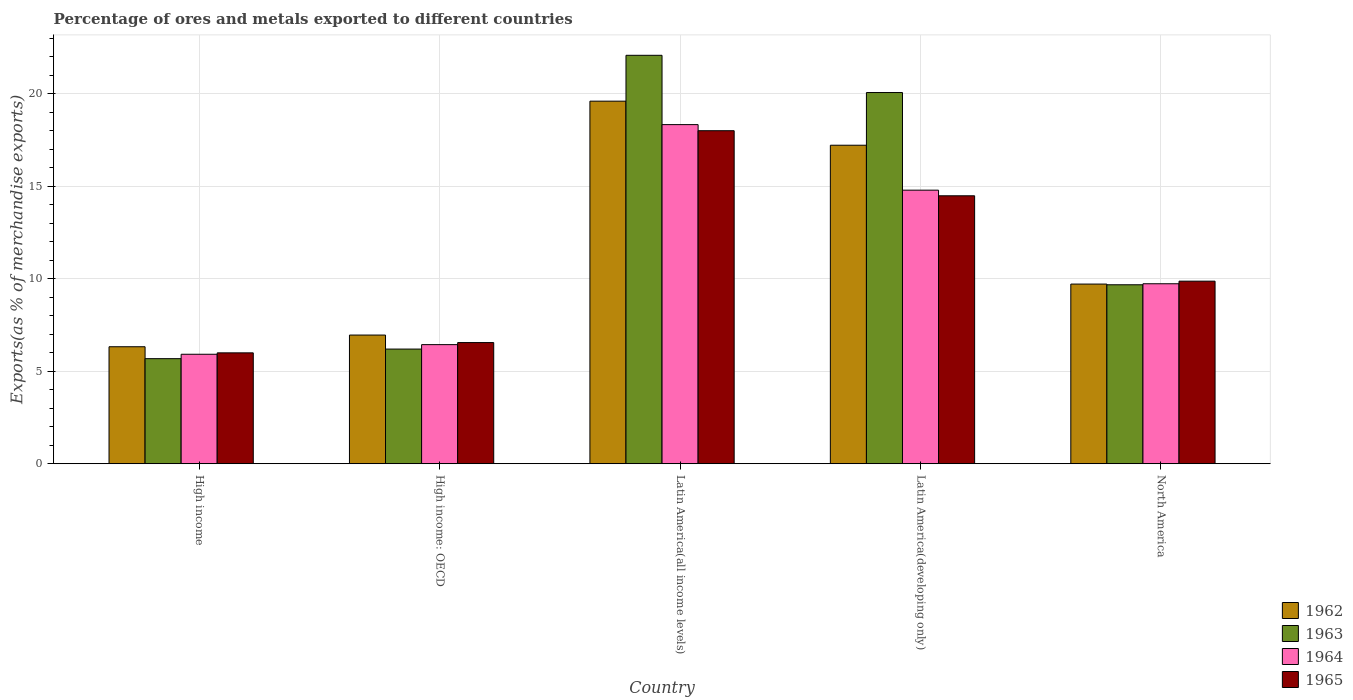Are the number of bars on each tick of the X-axis equal?
Your answer should be very brief. Yes. How many bars are there on the 5th tick from the right?
Make the answer very short. 4. What is the label of the 3rd group of bars from the left?
Your answer should be very brief. Latin America(all income levels). In how many cases, is the number of bars for a given country not equal to the number of legend labels?
Give a very brief answer. 0. What is the percentage of exports to different countries in 1962 in High income?
Ensure brevity in your answer.  6.33. Across all countries, what is the maximum percentage of exports to different countries in 1964?
Make the answer very short. 18.34. Across all countries, what is the minimum percentage of exports to different countries in 1965?
Provide a succinct answer. 6. In which country was the percentage of exports to different countries in 1965 maximum?
Make the answer very short. Latin America(all income levels). What is the total percentage of exports to different countries in 1964 in the graph?
Offer a very short reply. 55.24. What is the difference between the percentage of exports to different countries in 1962 in Latin America(developing only) and that in North America?
Make the answer very short. 7.51. What is the difference between the percentage of exports to different countries in 1962 in Latin America(developing only) and the percentage of exports to different countries in 1963 in Latin America(all income levels)?
Your answer should be very brief. -4.86. What is the average percentage of exports to different countries in 1964 per country?
Offer a terse response. 11.05. What is the difference between the percentage of exports to different countries of/in 1964 and percentage of exports to different countries of/in 1963 in Latin America(developing only)?
Offer a very short reply. -5.28. What is the ratio of the percentage of exports to different countries in 1962 in High income: OECD to that in Latin America(all income levels)?
Provide a succinct answer. 0.35. Is the percentage of exports to different countries in 1965 in High income: OECD less than that in North America?
Your answer should be compact. Yes. Is the difference between the percentage of exports to different countries in 1964 in High income and North America greater than the difference between the percentage of exports to different countries in 1963 in High income and North America?
Give a very brief answer. Yes. What is the difference between the highest and the second highest percentage of exports to different countries in 1963?
Your answer should be compact. -10.4. What is the difference between the highest and the lowest percentage of exports to different countries in 1965?
Give a very brief answer. 12.01. In how many countries, is the percentage of exports to different countries in 1963 greater than the average percentage of exports to different countries in 1963 taken over all countries?
Your answer should be compact. 2. Is the sum of the percentage of exports to different countries in 1962 in High income: OECD and Latin America(all income levels) greater than the maximum percentage of exports to different countries in 1965 across all countries?
Keep it short and to the point. Yes. Is it the case that in every country, the sum of the percentage of exports to different countries in 1962 and percentage of exports to different countries in 1964 is greater than the sum of percentage of exports to different countries in 1965 and percentage of exports to different countries in 1963?
Make the answer very short. No. What does the 3rd bar from the left in Latin America(all income levels) represents?
Keep it short and to the point. 1964. What does the 2nd bar from the right in North America represents?
Make the answer very short. 1964. Is it the case that in every country, the sum of the percentage of exports to different countries in 1962 and percentage of exports to different countries in 1965 is greater than the percentage of exports to different countries in 1963?
Ensure brevity in your answer.  Yes. Are the values on the major ticks of Y-axis written in scientific E-notation?
Give a very brief answer. No. Does the graph contain grids?
Ensure brevity in your answer.  Yes. How many legend labels are there?
Offer a very short reply. 4. What is the title of the graph?
Your answer should be very brief. Percentage of ores and metals exported to different countries. What is the label or title of the X-axis?
Your response must be concise. Country. What is the label or title of the Y-axis?
Your response must be concise. Exports(as % of merchandise exports). What is the Exports(as % of merchandise exports) in 1962 in High income?
Your answer should be compact. 6.33. What is the Exports(as % of merchandise exports) in 1963 in High income?
Your response must be concise. 5.68. What is the Exports(as % of merchandise exports) of 1964 in High income?
Ensure brevity in your answer.  5.92. What is the Exports(as % of merchandise exports) of 1965 in High income?
Offer a terse response. 6. What is the Exports(as % of merchandise exports) in 1962 in High income: OECD?
Your response must be concise. 6.96. What is the Exports(as % of merchandise exports) in 1963 in High income: OECD?
Provide a short and direct response. 6.2. What is the Exports(as % of merchandise exports) of 1964 in High income: OECD?
Provide a short and direct response. 6.44. What is the Exports(as % of merchandise exports) in 1965 in High income: OECD?
Make the answer very short. 6.55. What is the Exports(as % of merchandise exports) in 1962 in Latin America(all income levels)?
Keep it short and to the point. 19.61. What is the Exports(as % of merchandise exports) in 1963 in Latin America(all income levels)?
Ensure brevity in your answer.  22.09. What is the Exports(as % of merchandise exports) in 1964 in Latin America(all income levels)?
Provide a short and direct response. 18.34. What is the Exports(as % of merchandise exports) in 1965 in Latin America(all income levels)?
Make the answer very short. 18.01. What is the Exports(as % of merchandise exports) of 1962 in Latin America(developing only)?
Make the answer very short. 17.23. What is the Exports(as % of merchandise exports) in 1963 in Latin America(developing only)?
Your answer should be very brief. 20.08. What is the Exports(as % of merchandise exports) of 1964 in Latin America(developing only)?
Offer a very short reply. 14.8. What is the Exports(as % of merchandise exports) in 1965 in Latin America(developing only)?
Your answer should be very brief. 14.49. What is the Exports(as % of merchandise exports) of 1962 in North America?
Provide a short and direct response. 9.72. What is the Exports(as % of merchandise exports) of 1963 in North America?
Provide a succinct answer. 9.68. What is the Exports(as % of merchandise exports) of 1964 in North America?
Keep it short and to the point. 9.73. What is the Exports(as % of merchandise exports) in 1965 in North America?
Keep it short and to the point. 9.87. Across all countries, what is the maximum Exports(as % of merchandise exports) in 1962?
Provide a succinct answer. 19.61. Across all countries, what is the maximum Exports(as % of merchandise exports) of 1963?
Provide a short and direct response. 22.09. Across all countries, what is the maximum Exports(as % of merchandise exports) in 1964?
Ensure brevity in your answer.  18.34. Across all countries, what is the maximum Exports(as % of merchandise exports) in 1965?
Offer a very short reply. 18.01. Across all countries, what is the minimum Exports(as % of merchandise exports) of 1962?
Your response must be concise. 6.33. Across all countries, what is the minimum Exports(as % of merchandise exports) in 1963?
Give a very brief answer. 5.68. Across all countries, what is the minimum Exports(as % of merchandise exports) in 1964?
Provide a succinct answer. 5.92. Across all countries, what is the minimum Exports(as % of merchandise exports) in 1965?
Ensure brevity in your answer.  6. What is the total Exports(as % of merchandise exports) in 1962 in the graph?
Provide a short and direct response. 59.84. What is the total Exports(as % of merchandise exports) of 1963 in the graph?
Your answer should be compact. 63.73. What is the total Exports(as % of merchandise exports) of 1964 in the graph?
Your answer should be compact. 55.24. What is the total Exports(as % of merchandise exports) of 1965 in the graph?
Make the answer very short. 54.93. What is the difference between the Exports(as % of merchandise exports) in 1962 in High income and that in High income: OECD?
Offer a very short reply. -0.63. What is the difference between the Exports(as % of merchandise exports) of 1963 in High income and that in High income: OECD?
Offer a very short reply. -0.52. What is the difference between the Exports(as % of merchandise exports) of 1964 in High income and that in High income: OECD?
Your answer should be compact. -0.52. What is the difference between the Exports(as % of merchandise exports) in 1965 in High income and that in High income: OECD?
Make the answer very short. -0.56. What is the difference between the Exports(as % of merchandise exports) in 1962 in High income and that in Latin America(all income levels)?
Offer a very short reply. -13.28. What is the difference between the Exports(as % of merchandise exports) of 1963 in High income and that in Latin America(all income levels)?
Your response must be concise. -16.41. What is the difference between the Exports(as % of merchandise exports) in 1964 in High income and that in Latin America(all income levels)?
Keep it short and to the point. -12.42. What is the difference between the Exports(as % of merchandise exports) in 1965 in High income and that in Latin America(all income levels)?
Provide a short and direct response. -12.01. What is the difference between the Exports(as % of merchandise exports) in 1962 in High income and that in Latin America(developing only)?
Give a very brief answer. -10.9. What is the difference between the Exports(as % of merchandise exports) in 1963 in High income and that in Latin America(developing only)?
Provide a succinct answer. -14.39. What is the difference between the Exports(as % of merchandise exports) of 1964 in High income and that in Latin America(developing only)?
Give a very brief answer. -8.88. What is the difference between the Exports(as % of merchandise exports) in 1965 in High income and that in Latin America(developing only)?
Provide a short and direct response. -8.49. What is the difference between the Exports(as % of merchandise exports) in 1962 in High income and that in North America?
Your answer should be compact. -3.39. What is the difference between the Exports(as % of merchandise exports) of 1963 in High income and that in North America?
Your answer should be very brief. -4. What is the difference between the Exports(as % of merchandise exports) in 1964 in High income and that in North America?
Your response must be concise. -3.81. What is the difference between the Exports(as % of merchandise exports) in 1965 in High income and that in North America?
Provide a short and direct response. -3.88. What is the difference between the Exports(as % of merchandise exports) of 1962 in High income: OECD and that in Latin America(all income levels)?
Offer a very short reply. -12.65. What is the difference between the Exports(as % of merchandise exports) of 1963 in High income: OECD and that in Latin America(all income levels)?
Provide a short and direct response. -15.89. What is the difference between the Exports(as % of merchandise exports) in 1964 in High income: OECD and that in Latin America(all income levels)?
Offer a terse response. -11.9. What is the difference between the Exports(as % of merchandise exports) of 1965 in High income: OECD and that in Latin America(all income levels)?
Offer a terse response. -11.46. What is the difference between the Exports(as % of merchandise exports) of 1962 in High income: OECD and that in Latin America(developing only)?
Provide a short and direct response. -10.27. What is the difference between the Exports(as % of merchandise exports) in 1963 in High income: OECD and that in Latin America(developing only)?
Offer a terse response. -13.87. What is the difference between the Exports(as % of merchandise exports) of 1964 in High income: OECD and that in Latin America(developing only)?
Your answer should be very brief. -8.35. What is the difference between the Exports(as % of merchandise exports) in 1965 in High income: OECD and that in Latin America(developing only)?
Your answer should be very brief. -7.94. What is the difference between the Exports(as % of merchandise exports) of 1962 in High income: OECD and that in North America?
Your answer should be compact. -2.76. What is the difference between the Exports(as % of merchandise exports) in 1963 in High income: OECD and that in North America?
Your response must be concise. -3.48. What is the difference between the Exports(as % of merchandise exports) in 1964 in High income: OECD and that in North America?
Keep it short and to the point. -3.29. What is the difference between the Exports(as % of merchandise exports) of 1965 in High income: OECD and that in North America?
Make the answer very short. -3.32. What is the difference between the Exports(as % of merchandise exports) of 1962 in Latin America(all income levels) and that in Latin America(developing only)?
Ensure brevity in your answer.  2.38. What is the difference between the Exports(as % of merchandise exports) of 1963 in Latin America(all income levels) and that in Latin America(developing only)?
Your answer should be compact. 2.01. What is the difference between the Exports(as % of merchandise exports) in 1964 in Latin America(all income levels) and that in Latin America(developing only)?
Make the answer very short. 3.54. What is the difference between the Exports(as % of merchandise exports) in 1965 in Latin America(all income levels) and that in Latin America(developing only)?
Keep it short and to the point. 3.52. What is the difference between the Exports(as % of merchandise exports) in 1962 in Latin America(all income levels) and that in North America?
Your answer should be very brief. 9.89. What is the difference between the Exports(as % of merchandise exports) of 1963 in Latin America(all income levels) and that in North America?
Give a very brief answer. 12.41. What is the difference between the Exports(as % of merchandise exports) of 1964 in Latin America(all income levels) and that in North America?
Make the answer very short. 8.61. What is the difference between the Exports(as % of merchandise exports) of 1965 in Latin America(all income levels) and that in North America?
Provide a short and direct response. 8.14. What is the difference between the Exports(as % of merchandise exports) of 1962 in Latin America(developing only) and that in North America?
Offer a terse response. 7.51. What is the difference between the Exports(as % of merchandise exports) in 1963 in Latin America(developing only) and that in North America?
Make the answer very short. 10.4. What is the difference between the Exports(as % of merchandise exports) of 1964 in Latin America(developing only) and that in North America?
Your response must be concise. 5.06. What is the difference between the Exports(as % of merchandise exports) of 1965 in Latin America(developing only) and that in North America?
Your answer should be compact. 4.62. What is the difference between the Exports(as % of merchandise exports) in 1962 in High income and the Exports(as % of merchandise exports) in 1963 in High income: OECD?
Offer a terse response. 0.13. What is the difference between the Exports(as % of merchandise exports) of 1962 in High income and the Exports(as % of merchandise exports) of 1964 in High income: OECD?
Make the answer very short. -0.11. What is the difference between the Exports(as % of merchandise exports) of 1962 in High income and the Exports(as % of merchandise exports) of 1965 in High income: OECD?
Provide a succinct answer. -0.23. What is the difference between the Exports(as % of merchandise exports) of 1963 in High income and the Exports(as % of merchandise exports) of 1964 in High income: OECD?
Give a very brief answer. -0.76. What is the difference between the Exports(as % of merchandise exports) in 1963 in High income and the Exports(as % of merchandise exports) in 1965 in High income: OECD?
Offer a very short reply. -0.87. What is the difference between the Exports(as % of merchandise exports) of 1964 in High income and the Exports(as % of merchandise exports) of 1965 in High income: OECD?
Give a very brief answer. -0.63. What is the difference between the Exports(as % of merchandise exports) of 1962 in High income and the Exports(as % of merchandise exports) of 1963 in Latin America(all income levels)?
Make the answer very short. -15.76. What is the difference between the Exports(as % of merchandise exports) of 1962 in High income and the Exports(as % of merchandise exports) of 1964 in Latin America(all income levels)?
Make the answer very short. -12.01. What is the difference between the Exports(as % of merchandise exports) in 1962 in High income and the Exports(as % of merchandise exports) in 1965 in Latin America(all income levels)?
Offer a very short reply. -11.68. What is the difference between the Exports(as % of merchandise exports) of 1963 in High income and the Exports(as % of merchandise exports) of 1964 in Latin America(all income levels)?
Make the answer very short. -12.66. What is the difference between the Exports(as % of merchandise exports) of 1963 in High income and the Exports(as % of merchandise exports) of 1965 in Latin America(all income levels)?
Your answer should be very brief. -12.33. What is the difference between the Exports(as % of merchandise exports) of 1964 in High income and the Exports(as % of merchandise exports) of 1965 in Latin America(all income levels)?
Offer a very short reply. -12.09. What is the difference between the Exports(as % of merchandise exports) in 1962 in High income and the Exports(as % of merchandise exports) in 1963 in Latin America(developing only)?
Make the answer very short. -13.75. What is the difference between the Exports(as % of merchandise exports) in 1962 in High income and the Exports(as % of merchandise exports) in 1964 in Latin America(developing only)?
Provide a succinct answer. -8.47. What is the difference between the Exports(as % of merchandise exports) in 1962 in High income and the Exports(as % of merchandise exports) in 1965 in Latin America(developing only)?
Make the answer very short. -8.16. What is the difference between the Exports(as % of merchandise exports) in 1963 in High income and the Exports(as % of merchandise exports) in 1964 in Latin America(developing only)?
Keep it short and to the point. -9.11. What is the difference between the Exports(as % of merchandise exports) in 1963 in High income and the Exports(as % of merchandise exports) in 1965 in Latin America(developing only)?
Make the answer very short. -8.81. What is the difference between the Exports(as % of merchandise exports) of 1964 in High income and the Exports(as % of merchandise exports) of 1965 in Latin America(developing only)?
Offer a very short reply. -8.57. What is the difference between the Exports(as % of merchandise exports) in 1962 in High income and the Exports(as % of merchandise exports) in 1963 in North America?
Ensure brevity in your answer.  -3.35. What is the difference between the Exports(as % of merchandise exports) of 1962 in High income and the Exports(as % of merchandise exports) of 1964 in North America?
Your answer should be very brief. -3.41. What is the difference between the Exports(as % of merchandise exports) of 1962 in High income and the Exports(as % of merchandise exports) of 1965 in North America?
Offer a very short reply. -3.55. What is the difference between the Exports(as % of merchandise exports) of 1963 in High income and the Exports(as % of merchandise exports) of 1964 in North America?
Provide a short and direct response. -4.05. What is the difference between the Exports(as % of merchandise exports) in 1963 in High income and the Exports(as % of merchandise exports) in 1965 in North America?
Your answer should be very brief. -4.19. What is the difference between the Exports(as % of merchandise exports) of 1964 in High income and the Exports(as % of merchandise exports) of 1965 in North America?
Keep it short and to the point. -3.95. What is the difference between the Exports(as % of merchandise exports) of 1962 in High income: OECD and the Exports(as % of merchandise exports) of 1963 in Latin America(all income levels)?
Offer a terse response. -15.13. What is the difference between the Exports(as % of merchandise exports) of 1962 in High income: OECD and the Exports(as % of merchandise exports) of 1964 in Latin America(all income levels)?
Your answer should be very brief. -11.38. What is the difference between the Exports(as % of merchandise exports) of 1962 in High income: OECD and the Exports(as % of merchandise exports) of 1965 in Latin America(all income levels)?
Keep it short and to the point. -11.05. What is the difference between the Exports(as % of merchandise exports) in 1963 in High income: OECD and the Exports(as % of merchandise exports) in 1964 in Latin America(all income levels)?
Offer a terse response. -12.14. What is the difference between the Exports(as % of merchandise exports) of 1963 in High income: OECD and the Exports(as % of merchandise exports) of 1965 in Latin America(all income levels)?
Make the answer very short. -11.81. What is the difference between the Exports(as % of merchandise exports) of 1964 in High income: OECD and the Exports(as % of merchandise exports) of 1965 in Latin America(all income levels)?
Your response must be concise. -11.57. What is the difference between the Exports(as % of merchandise exports) in 1962 in High income: OECD and the Exports(as % of merchandise exports) in 1963 in Latin America(developing only)?
Provide a succinct answer. -13.12. What is the difference between the Exports(as % of merchandise exports) of 1962 in High income: OECD and the Exports(as % of merchandise exports) of 1964 in Latin America(developing only)?
Provide a succinct answer. -7.84. What is the difference between the Exports(as % of merchandise exports) in 1962 in High income: OECD and the Exports(as % of merchandise exports) in 1965 in Latin America(developing only)?
Your answer should be compact. -7.53. What is the difference between the Exports(as % of merchandise exports) of 1963 in High income: OECD and the Exports(as % of merchandise exports) of 1964 in Latin America(developing only)?
Your answer should be compact. -8.59. What is the difference between the Exports(as % of merchandise exports) of 1963 in High income: OECD and the Exports(as % of merchandise exports) of 1965 in Latin America(developing only)?
Offer a very short reply. -8.29. What is the difference between the Exports(as % of merchandise exports) of 1964 in High income: OECD and the Exports(as % of merchandise exports) of 1965 in Latin America(developing only)?
Ensure brevity in your answer.  -8.05. What is the difference between the Exports(as % of merchandise exports) of 1962 in High income: OECD and the Exports(as % of merchandise exports) of 1963 in North America?
Make the answer very short. -2.72. What is the difference between the Exports(as % of merchandise exports) in 1962 in High income: OECD and the Exports(as % of merchandise exports) in 1964 in North America?
Your answer should be compact. -2.77. What is the difference between the Exports(as % of merchandise exports) in 1962 in High income: OECD and the Exports(as % of merchandise exports) in 1965 in North America?
Offer a very short reply. -2.91. What is the difference between the Exports(as % of merchandise exports) in 1963 in High income: OECD and the Exports(as % of merchandise exports) in 1964 in North America?
Give a very brief answer. -3.53. What is the difference between the Exports(as % of merchandise exports) of 1963 in High income: OECD and the Exports(as % of merchandise exports) of 1965 in North America?
Your response must be concise. -3.67. What is the difference between the Exports(as % of merchandise exports) in 1964 in High income: OECD and the Exports(as % of merchandise exports) in 1965 in North America?
Offer a very short reply. -3.43. What is the difference between the Exports(as % of merchandise exports) in 1962 in Latin America(all income levels) and the Exports(as % of merchandise exports) in 1963 in Latin America(developing only)?
Ensure brevity in your answer.  -0.47. What is the difference between the Exports(as % of merchandise exports) of 1962 in Latin America(all income levels) and the Exports(as % of merchandise exports) of 1964 in Latin America(developing only)?
Your answer should be very brief. 4.81. What is the difference between the Exports(as % of merchandise exports) of 1962 in Latin America(all income levels) and the Exports(as % of merchandise exports) of 1965 in Latin America(developing only)?
Offer a very short reply. 5.12. What is the difference between the Exports(as % of merchandise exports) of 1963 in Latin America(all income levels) and the Exports(as % of merchandise exports) of 1964 in Latin America(developing only)?
Offer a very short reply. 7.29. What is the difference between the Exports(as % of merchandise exports) in 1963 in Latin America(all income levels) and the Exports(as % of merchandise exports) in 1965 in Latin America(developing only)?
Give a very brief answer. 7.6. What is the difference between the Exports(as % of merchandise exports) of 1964 in Latin America(all income levels) and the Exports(as % of merchandise exports) of 1965 in Latin America(developing only)?
Give a very brief answer. 3.85. What is the difference between the Exports(as % of merchandise exports) of 1962 in Latin America(all income levels) and the Exports(as % of merchandise exports) of 1963 in North America?
Provide a short and direct response. 9.93. What is the difference between the Exports(as % of merchandise exports) of 1962 in Latin America(all income levels) and the Exports(as % of merchandise exports) of 1964 in North America?
Your answer should be very brief. 9.88. What is the difference between the Exports(as % of merchandise exports) of 1962 in Latin America(all income levels) and the Exports(as % of merchandise exports) of 1965 in North America?
Keep it short and to the point. 9.73. What is the difference between the Exports(as % of merchandise exports) in 1963 in Latin America(all income levels) and the Exports(as % of merchandise exports) in 1964 in North America?
Provide a short and direct response. 12.36. What is the difference between the Exports(as % of merchandise exports) in 1963 in Latin America(all income levels) and the Exports(as % of merchandise exports) in 1965 in North America?
Offer a terse response. 12.22. What is the difference between the Exports(as % of merchandise exports) of 1964 in Latin America(all income levels) and the Exports(as % of merchandise exports) of 1965 in North America?
Offer a terse response. 8.47. What is the difference between the Exports(as % of merchandise exports) of 1962 in Latin America(developing only) and the Exports(as % of merchandise exports) of 1963 in North America?
Ensure brevity in your answer.  7.55. What is the difference between the Exports(as % of merchandise exports) in 1962 in Latin America(developing only) and the Exports(as % of merchandise exports) in 1964 in North America?
Ensure brevity in your answer.  7.49. What is the difference between the Exports(as % of merchandise exports) in 1962 in Latin America(developing only) and the Exports(as % of merchandise exports) in 1965 in North America?
Ensure brevity in your answer.  7.35. What is the difference between the Exports(as % of merchandise exports) in 1963 in Latin America(developing only) and the Exports(as % of merchandise exports) in 1964 in North America?
Ensure brevity in your answer.  10.34. What is the difference between the Exports(as % of merchandise exports) of 1963 in Latin America(developing only) and the Exports(as % of merchandise exports) of 1965 in North America?
Give a very brief answer. 10.2. What is the difference between the Exports(as % of merchandise exports) of 1964 in Latin America(developing only) and the Exports(as % of merchandise exports) of 1965 in North America?
Ensure brevity in your answer.  4.92. What is the average Exports(as % of merchandise exports) in 1962 per country?
Your response must be concise. 11.97. What is the average Exports(as % of merchandise exports) in 1963 per country?
Offer a very short reply. 12.75. What is the average Exports(as % of merchandise exports) in 1964 per country?
Make the answer very short. 11.05. What is the average Exports(as % of merchandise exports) of 1965 per country?
Make the answer very short. 10.99. What is the difference between the Exports(as % of merchandise exports) in 1962 and Exports(as % of merchandise exports) in 1963 in High income?
Give a very brief answer. 0.64. What is the difference between the Exports(as % of merchandise exports) in 1962 and Exports(as % of merchandise exports) in 1964 in High income?
Your answer should be very brief. 0.41. What is the difference between the Exports(as % of merchandise exports) in 1962 and Exports(as % of merchandise exports) in 1965 in High income?
Offer a very short reply. 0.33. What is the difference between the Exports(as % of merchandise exports) in 1963 and Exports(as % of merchandise exports) in 1964 in High income?
Provide a succinct answer. -0.24. What is the difference between the Exports(as % of merchandise exports) in 1963 and Exports(as % of merchandise exports) in 1965 in High income?
Keep it short and to the point. -0.31. What is the difference between the Exports(as % of merchandise exports) of 1964 and Exports(as % of merchandise exports) of 1965 in High income?
Ensure brevity in your answer.  -0.08. What is the difference between the Exports(as % of merchandise exports) in 1962 and Exports(as % of merchandise exports) in 1963 in High income: OECD?
Your answer should be very brief. 0.76. What is the difference between the Exports(as % of merchandise exports) in 1962 and Exports(as % of merchandise exports) in 1964 in High income: OECD?
Ensure brevity in your answer.  0.52. What is the difference between the Exports(as % of merchandise exports) of 1962 and Exports(as % of merchandise exports) of 1965 in High income: OECD?
Offer a very short reply. 0.41. What is the difference between the Exports(as % of merchandise exports) of 1963 and Exports(as % of merchandise exports) of 1964 in High income: OECD?
Offer a very short reply. -0.24. What is the difference between the Exports(as % of merchandise exports) in 1963 and Exports(as % of merchandise exports) in 1965 in High income: OECD?
Provide a short and direct response. -0.35. What is the difference between the Exports(as % of merchandise exports) of 1964 and Exports(as % of merchandise exports) of 1965 in High income: OECD?
Your answer should be compact. -0.11. What is the difference between the Exports(as % of merchandise exports) in 1962 and Exports(as % of merchandise exports) in 1963 in Latin America(all income levels)?
Provide a succinct answer. -2.48. What is the difference between the Exports(as % of merchandise exports) of 1962 and Exports(as % of merchandise exports) of 1964 in Latin America(all income levels)?
Your answer should be compact. 1.27. What is the difference between the Exports(as % of merchandise exports) in 1962 and Exports(as % of merchandise exports) in 1965 in Latin America(all income levels)?
Provide a succinct answer. 1.6. What is the difference between the Exports(as % of merchandise exports) in 1963 and Exports(as % of merchandise exports) in 1964 in Latin America(all income levels)?
Provide a short and direct response. 3.75. What is the difference between the Exports(as % of merchandise exports) of 1963 and Exports(as % of merchandise exports) of 1965 in Latin America(all income levels)?
Give a very brief answer. 4.08. What is the difference between the Exports(as % of merchandise exports) in 1964 and Exports(as % of merchandise exports) in 1965 in Latin America(all income levels)?
Offer a terse response. 0.33. What is the difference between the Exports(as % of merchandise exports) in 1962 and Exports(as % of merchandise exports) in 1963 in Latin America(developing only)?
Provide a short and direct response. -2.85. What is the difference between the Exports(as % of merchandise exports) in 1962 and Exports(as % of merchandise exports) in 1964 in Latin America(developing only)?
Provide a succinct answer. 2.43. What is the difference between the Exports(as % of merchandise exports) of 1962 and Exports(as % of merchandise exports) of 1965 in Latin America(developing only)?
Your response must be concise. 2.73. What is the difference between the Exports(as % of merchandise exports) of 1963 and Exports(as % of merchandise exports) of 1964 in Latin America(developing only)?
Your answer should be very brief. 5.28. What is the difference between the Exports(as % of merchandise exports) of 1963 and Exports(as % of merchandise exports) of 1965 in Latin America(developing only)?
Ensure brevity in your answer.  5.58. What is the difference between the Exports(as % of merchandise exports) of 1964 and Exports(as % of merchandise exports) of 1965 in Latin America(developing only)?
Make the answer very short. 0.3. What is the difference between the Exports(as % of merchandise exports) in 1962 and Exports(as % of merchandise exports) in 1963 in North America?
Give a very brief answer. 0.04. What is the difference between the Exports(as % of merchandise exports) of 1962 and Exports(as % of merchandise exports) of 1964 in North America?
Ensure brevity in your answer.  -0.02. What is the difference between the Exports(as % of merchandise exports) in 1962 and Exports(as % of merchandise exports) in 1965 in North America?
Your response must be concise. -0.16. What is the difference between the Exports(as % of merchandise exports) in 1963 and Exports(as % of merchandise exports) in 1964 in North America?
Make the answer very short. -0.06. What is the difference between the Exports(as % of merchandise exports) in 1963 and Exports(as % of merchandise exports) in 1965 in North America?
Offer a very short reply. -0.2. What is the difference between the Exports(as % of merchandise exports) of 1964 and Exports(as % of merchandise exports) of 1965 in North America?
Provide a short and direct response. -0.14. What is the ratio of the Exports(as % of merchandise exports) of 1963 in High income to that in High income: OECD?
Keep it short and to the point. 0.92. What is the ratio of the Exports(as % of merchandise exports) of 1964 in High income to that in High income: OECD?
Your answer should be compact. 0.92. What is the ratio of the Exports(as % of merchandise exports) of 1965 in High income to that in High income: OECD?
Offer a terse response. 0.92. What is the ratio of the Exports(as % of merchandise exports) of 1962 in High income to that in Latin America(all income levels)?
Give a very brief answer. 0.32. What is the ratio of the Exports(as % of merchandise exports) of 1963 in High income to that in Latin America(all income levels)?
Provide a short and direct response. 0.26. What is the ratio of the Exports(as % of merchandise exports) in 1964 in High income to that in Latin America(all income levels)?
Offer a terse response. 0.32. What is the ratio of the Exports(as % of merchandise exports) in 1965 in High income to that in Latin America(all income levels)?
Provide a succinct answer. 0.33. What is the ratio of the Exports(as % of merchandise exports) of 1962 in High income to that in Latin America(developing only)?
Make the answer very short. 0.37. What is the ratio of the Exports(as % of merchandise exports) of 1963 in High income to that in Latin America(developing only)?
Provide a succinct answer. 0.28. What is the ratio of the Exports(as % of merchandise exports) of 1964 in High income to that in Latin America(developing only)?
Make the answer very short. 0.4. What is the ratio of the Exports(as % of merchandise exports) of 1965 in High income to that in Latin America(developing only)?
Your answer should be very brief. 0.41. What is the ratio of the Exports(as % of merchandise exports) in 1962 in High income to that in North America?
Your answer should be very brief. 0.65. What is the ratio of the Exports(as % of merchandise exports) of 1963 in High income to that in North America?
Provide a short and direct response. 0.59. What is the ratio of the Exports(as % of merchandise exports) of 1964 in High income to that in North America?
Your response must be concise. 0.61. What is the ratio of the Exports(as % of merchandise exports) of 1965 in High income to that in North America?
Keep it short and to the point. 0.61. What is the ratio of the Exports(as % of merchandise exports) of 1962 in High income: OECD to that in Latin America(all income levels)?
Keep it short and to the point. 0.35. What is the ratio of the Exports(as % of merchandise exports) of 1963 in High income: OECD to that in Latin America(all income levels)?
Make the answer very short. 0.28. What is the ratio of the Exports(as % of merchandise exports) of 1964 in High income: OECD to that in Latin America(all income levels)?
Provide a short and direct response. 0.35. What is the ratio of the Exports(as % of merchandise exports) in 1965 in High income: OECD to that in Latin America(all income levels)?
Give a very brief answer. 0.36. What is the ratio of the Exports(as % of merchandise exports) in 1962 in High income: OECD to that in Latin America(developing only)?
Offer a very short reply. 0.4. What is the ratio of the Exports(as % of merchandise exports) in 1963 in High income: OECD to that in Latin America(developing only)?
Keep it short and to the point. 0.31. What is the ratio of the Exports(as % of merchandise exports) of 1964 in High income: OECD to that in Latin America(developing only)?
Give a very brief answer. 0.44. What is the ratio of the Exports(as % of merchandise exports) in 1965 in High income: OECD to that in Latin America(developing only)?
Ensure brevity in your answer.  0.45. What is the ratio of the Exports(as % of merchandise exports) in 1962 in High income: OECD to that in North America?
Keep it short and to the point. 0.72. What is the ratio of the Exports(as % of merchandise exports) of 1963 in High income: OECD to that in North America?
Your answer should be very brief. 0.64. What is the ratio of the Exports(as % of merchandise exports) in 1964 in High income: OECD to that in North America?
Your response must be concise. 0.66. What is the ratio of the Exports(as % of merchandise exports) of 1965 in High income: OECD to that in North America?
Provide a succinct answer. 0.66. What is the ratio of the Exports(as % of merchandise exports) of 1962 in Latin America(all income levels) to that in Latin America(developing only)?
Give a very brief answer. 1.14. What is the ratio of the Exports(as % of merchandise exports) in 1963 in Latin America(all income levels) to that in Latin America(developing only)?
Your response must be concise. 1.1. What is the ratio of the Exports(as % of merchandise exports) of 1964 in Latin America(all income levels) to that in Latin America(developing only)?
Provide a short and direct response. 1.24. What is the ratio of the Exports(as % of merchandise exports) in 1965 in Latin America(all income levels) to that in Latin America(developing only)?
Make the answer very short. 1.24. What is the ratio of the Exports(as % of merchandise exports) of 1962 in Latin America(all income levels) to that in North America?
Offer a terse response. 2.02. What is the ratio of the Exports(as % of merchandise exports) in 1963 in Latin America(all income levels) to that in North America?
Provide a succinct answer. 2.28. What is the ratio of the Exports(as % of merchandise exports) in 1964 in Latin America(all income levels) to that in North America?
Your answer should be very brief. 1.88. What is the ratio of the Exports(as % of merchandise exports) of 1965 in Latin America(all income levels) to that in North America?
Your answer should be compact. 1.82. What is the ratio of the Exports(as % of merchandise exports) of 1962 in Latin America(developing only) to that in North America?
Provide a short and direct response. 1.77. What is the ratio of the Exports(as % of merchandise exports) in 1963 in Latin America(developing only) to that in North America?
Offer a terse response. 2.07. What is the ratio of the Exports(as % of merchandise exports) in 1964 in Latin America(developing only) to that in North America?
Offer a terse response. 1.52. What is the ratio of the Exports(as % of merchandise exports) in 1965 in Latin America(developing only) to that in North America?
Your answer should be compact. 1.47. What is the difference between the highest and the second highest Exports(as % of merchandise exports) of 1962?
Make the answer very short. 2.38. What is the difference between the highest and the second highest Exports(as % of merchandise exports) in 1963?
Your answer should be very brief. 2.01. What is the difference between the highest and the second highest Exports(as % of merchandise exports) of 1964?
Make the answer very short. 3.54. What is the difference between the highest and the second highest Exports(as % of merchandise exports) of 1965?
Your response must be concise. 3.52. What is the difference between the highest and the lowest Exports(as % of merchandise exports) of 1962?
Provide a short and direct response. 13.28. What is the difference between the highest and the lowest Exports(as % of merchandise exports) of 1963?
Provide a short and direct response. 16.41. What is the difference between the highest and the lowest Exports(as % of merchandise exports) in 1964?
Ensure brevity in your answer.  12.42. What is the difference between the highest and the lowest Exports(as % of merchandise exports) in 1965?
Your answer should be compact. 12.01. 